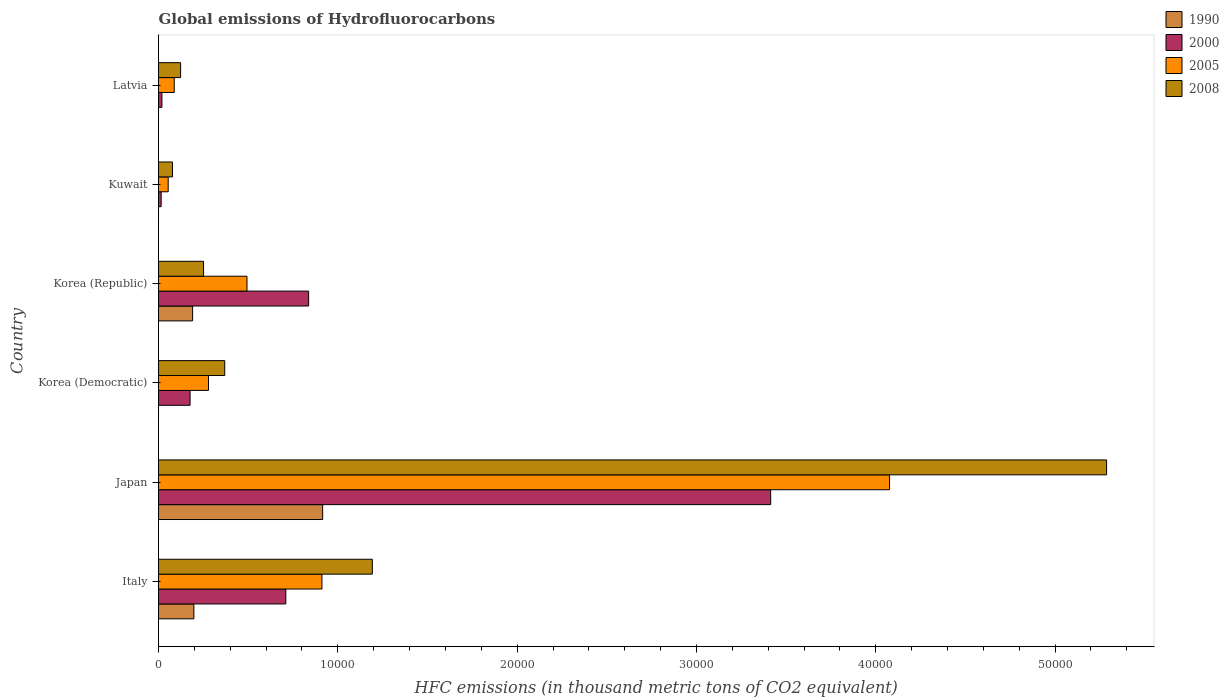How many groups of bars are there?
Make the answer very short. 6. Are the number of bars per tick equal to the number of legend labels?
Offer a very short reply. Yes. How many bars are there on the 6th tick from the bottom?
Keep it short and to the point. 4. What is the global emissions of Hydrofluorocarbons in 2005 in Korea (Republic)?
Keep it short and to the point. 4933.9. Across all countries, what is the maximum global emissions of Hydrofluorocarbons in 2005?
Provide a short and direct response. 4.08e+04. Across all countries, what is the minimum global emissions of Hydrofluorocarbons in 2008?
Ensure brevity in your answer.  779. In which country was the global emissions of Hydrofluorocarbons in 2005 minimum?
Provide a short and direct response. Kuwait. What is the total global emissions of Hydrofluorocarbons in 2000 in the graph?
Offer a very short reply. 5.17e+04. What is the difference between the global emissions of Hydrofluorocarbons in 2005 in Korea (Republic) and that in Latvia?
Give a very brief answer. 4057.3. What is the difference between the global emissions of Hydrofluorocarbons in 1990 in Japan and the global emissions of Hydrofluorocarbons in 2008 in Italy?
Offer a very short reply. -2770.2. What is the average global emissions of Hydrofluorocarbons in 1990 per country?
Your answer should be compact. 2171.43. What is the difference between the global emissions of Hydrofluorocarbons in 1990 and global emissions of Hydrofluorocarbons in 2000 in Kuwait?
Ensure brevity in your answer.  -147.2. What is the ratio of the global emissions of Hydrofluorocarbons in 2000 in Japan to that in Latvia?
Make the answer very short. 179.68. Is the global emissions of Hydrofluorocarbons in 2005 in Italy less than that in Japan?
Your answer should be compact. Yes. Is the difference between the global emissions of Hydrofluorocarbons in 1990 in Korea (Democratic) and Kuwait greater than the difference between the global emissions of Hydrofluorocarbons in 2000 in Korea (Democratic) and Kuwait?
Provide a succinct answer. No. What is the difference between the highest and the second highest global emissions of Hydrofluorocarbons in 1990?
Make the answer very short. 7182.1. What is the difference between the highest and the lowest global emissions of Hydrofluorocarbons in 2008?
Keep it short and to the point. 5.21e+04. In how many countries, is the global emissions of Hydrofluorocarbons in 2005 greater than the average global emissions of Hydrofluorocarbons in 2005 taken over all countries?
Offer a very short reply. 1. Is the sum of the global emissions of Hydrofluorocarbons in 2005 in Italy and Korea (Democratic) greater than the maximum global emissions of Hydrofluorocarbons in 2008 across all countries?
Your answer should be very brief. No. Is it the case that in every country, the sum of the global emissions of Hydrofluorocarbons in 2008 and global emissions of Hydrofluorocarbons in 2005 is greater than the global emissions of Hydrofluorocarbons in 1990?
Offer a very short reply. Yes. How many bars are there?
Your answer should be very brief. 24. What is the difference between two consecutive major ticks on the X-axis?
Provide a succinct answer. 10000. What is the title of the graph?
Your response must be concise. Global emissions of Hydrofluorocarbons. What is the label or title of the X-axis?
Your answer should be very brief. HFC emissions (in thousand metric tons of CO2 equivalent). What is the label or title of the Y-axis?
Your answer should be very brief. Country. What is the HFC emissions (in thousand metric tons of CO2 equivalent) of 1990 in Italy?
Ensure brevity in your answer.  1972.2. What is the HFC emissions (in thousand metric tons of CO2 equivalent) in 2000 in Italy?
Provide a succinct answer. 7099.5. What is the HFC emissions (in thousand metric tons of CO2 equivalent) of 2005 in Italy?
Give a very brief answer. 9114.5. What is the HFC emissions (in thousand metric tons of CO2 equivalent) in 2008 in Italy?
Make the answer very short. 1.19e+04. What is the HFC emissions (in thousand metric tons of CO2 equivalent) in 1990 in Japan?
Give a very brief answer. 9154.3. What is the HFC emissions (in thousand metric tons of CO2 equivalent) in 2000 in Japan?
Offer a very short reply. 3.41e+04. What is the HFC emissions (in thousand metric tons of CO2 equivalent) of 2005 in Japan?
Offer a very short reply. 4.08e+04. What is the HFC emissions (in thousand metric tons of CO2 equivalent) of 2008 in Japan?
Your answer should be compact. 5.29e+04. What is the HFC emissions (in thousand metric tons of CO2 equivalent) of 1990 in Korea (Democratic)?
Your answer should be very brief. 0.2. What is the HFC emissions (in thousand metric tons of CO2 equivalent) in 2000 in Korea (Democratic)?
Ensure brevity in your answer.  1760.1. What is the HFC emissions (in thousand metric tons of CO2 equivalent) in 2005 in Korea (Democratic)?
Make the answer very short. 2787.1. What is the HFC emissions (in thousand metric tons of CO2 equivalent) of 2008 in Korea (Democratic)?
Provide a short and direct response. 3693.8. What is the HFC emissions (in thousand metric tons of CO2 equivalent) of 1990 in Korea (Republic)?
Offer a terse response. 1901.7. What is the HFC emissions (in thousand metric tons of CO2 equivalent) of 2000 in Korea (Republic)?
Ensure brevity in your answer.  8371.9. What is the HFC emissions (in thousand metric tons of CO2 equivalent) of 2005 in Korea (Republic)?
Offer a very short reply. 4933.9. What is the HFC emissions (in thousand metric tons of CO2 equivalent) of 2008 in Korea (Republic)?
Provide a succinct answer. 2511.2. What is the HFC emissions (in thousand metric tons of CO2 equivalent) of 1990 in Kuwait?
Provide a short and direct response. 0.1. What is the HFC emissions (in thousand metric tons of CO2 equivalent) in 2000 in Kuwait?
Your response must be concise. 147.3. What is the HFC emissions (in thousand metric tons of CO2 equivalent) in 2005 in Kuwait?
Keep it short and to the point. 539.6. What is the HFC emissions (in thousand metric tons of CO2 equivalent) of 2008 in Kuwait?
Offer a very short reply. 779. What is the HFC emissions (in thousand metric tons of CO2 equivalent) in 2000 in Latvia?
Offer a terse response. 190. What is the HFC emissions (in thousand metric tons of CO2 equivalent) of 2005 in Latvia?
Make the answer very short. 876.6. What is the HFC emissions (in thousand metric tons of CO2 equivalent) of 2008 in Latvia?
Provide a succinct answer. 1233.1. Across all countries, what is the maximum HFC emissions (in thousand metric tons of CO2 equivalent) of 1990?
Provide a short and direct response. 9154.3. Across all countries, what is the maximum HFC emissions (in thousand metric tons of CO2 equivalent) of 2000?
Provide a succinct answer. 3.41e+04. Across all countries, what is the maximum HFC emissions (in thousand metric tons of CO2 equivalent) in 2005?
Provide a short and direct response. 4.08e+04. Across all countries, what is the maximum HFC emissions (in thousand metric tons of CO2 equivalent) in 2008?
Keep it short and to the point. 5.29e+04. Across all countries, what is the minimum HFC emissions (in thousand metric tons of CO2 equivalent) of 2000?
Your answer should be compact. 147.3. Across all countries, what is the minimum HFC emissions (in thousand metric tons of CO2 equivalent) in 2005?
Your response must be concise. 539.6. Across all countries, what is the minimum HFC emissions (in thousand metric tons of CO2 equivalent) of 2008?
Give a very brief answer. 779. What is the total HFC emissions (in thousand metric tons of CO2 equivalent) of 1990 in the graph?
Give a very brief answer. 1.30e+04. What is the total HFC emissions (in thousand metric tons of CO2 equivalent) of 2000 in the graph?
Keep it short and to the point. 5.17e+04. What is the total HFC emissions (in thousand metric tons of CO2 equivalent) in 2005 in the graph?
Your answer should be compact. 5.90e+04. What is the total HFC emissions (in thousand metric tons of CO2 equivalent) in 2008 in the graph?
Your answer should be very brief. 7.30e+04. What is the difference between the HFC emissions (in thousand metric tons of CO2 equivalent) in 1990 in Italy and that in Japan?
Provide a short and direct response. -7182.1. What is the difference between the HFC emissions (in thousand metric tons of CO2 equivalent) of 2000 in Italy and that in Japan?
Give a very brief answer. -2.70e+04. What is the difference between the HFC emissions (in thousand metric tons of CO2 equivalent) of 2005 in Italy and that in Japan?
Give a very brief answer. -3.17e+04. What is the difference between the HFC emissions (in thousand metric tons of CO2 equivalent) of 2008 in Italy and that in Japan?
Your response must be concise. -4.09e+04. What is the difference between the HFC emissions (in thousand metric tons of CO2 equivalent) in 1990 in Italy and that in Korea (Democratic)?
Provide a short and direct response. 1972. What is the difference between the HFC emissions (in thousand metric tons of CO2 equivalent) of 2000 in Italy and that in Korea (Democratic)?
Your answer should be compact. 5339.4. What is the difference between the HFC emissions (in thousand metric tons of CO2 equivalent) in 2005 in Italy and that in Korea (Democratic)?
Make the answer very short. 6327.4. What is the difference between the HFC emissions (in thousand metric tons of CO2 equivalent) of 2008 in Italy and that in Korea (Democratic)?
Provide a succinct answer. 8230.7. What is the difference between the HFC emissions (in thousand metric tons of CO2 equivalent) in 1990 in Italy and that in Korea (Republic)?
Offer a terse response. 70.5. What is the difference between the HFC emissions (in thousand metric tons of CO2 equivalent) in 2000 in Italy and that in Korea (Republic)?
Your answer should be compact. -1272.4. What is the difference between the HFC emissions (in thousand metric tons of CO2 equivalent) of 2005 in Italy and that in Korea (Republic)?
Your answer should be compact. 4180.6. What is the difference between the HFC emissions (in thousand metric tons of CO2 equivalent) of 2008 in Italy and that in Korea (Republic)?
Offer a terse response. 9413.3. What is the difference between the HFC emissions (in thousand metric tons of CO2 equivalent) of 1990 in Italy and that in Kuwait?
Your answer should be compact. 1972.1. What is the difference between the HFC emissions (in thousand metric tons of CO2 equivalent) in 2000 in Italy and that in Kuwait?
Your answer should be compact. 6952.2. What is the difference between the HFC emissions (in thousand metric tons of CO2 equivalent) of 2005 in Italy and that in Kuwait?
Provide a short and direct response. 8574.9. What is the difference between the HFC emissions (in thousand metric tons of CO2 equivalent) of 2008 in Italy and that in Kuwait?
Provide a short and direct response. 1.11e+04. What is the difference between the HFC emissions (in thousand metric tons of CO2 equivalent) in 1990 in Italy and that in Latvia?
Provide a short and direct response. 1972.1. What is the difference between the HFC emissions (in thousand metric tons of CO2 equivalent) of 2000 in Italy and that in Latvia?
Give a very brief answer. 6909.5. What is the difference between the HFC emissions (in thousand metric tons of CO2 equivalent) in 2005 in Italy and that in Latvia?
Give a very brief answer. 8237.9. What is the difference between the HFC emissions (in thousand metric tons of CO2 equivalent) in 2008 in Italy and that in Latvia?
Your response must be concise. 1.07e+04. What is the difference between the HFC emissions (in thousand metric tons of CO2 equivalent) in 1990 in Japan and that in Korea (Democratic)?
Make the answer very short. 9154.1. What is the difference between the HFC emissions (in thousand metric tons of CO2 equivalent) of 2000 in Japan and that in Korea (Democratic)?
Provide a short and direct response. 3.24e+04. What is the difference between the HFC emissions (in thousand metric tons of CO2 equivalent) of 2005 in Japan and that in Korea (Democratic)?
Your answer should be compact. 3.80e+04. What is the difference between the HFC emissions (in thousand metric tons of CO2 equivalent) of 2008 in Japan and that in Korea (Democratic)?
Keep it short and to the point. 4.92e+04. What is the difference between the HFC emissions (in thousand metric tons of CO2 equivalent) in 1990 in Japan and that in Korea (Republic)?
Your answer should be very brief. 7252.6. What is the difference between the HFC emissions (in thousand metric tons of CO2 equivalent) of 2000 in Japan and that in Korea (Republic)?
Offer a very short reply. 2.58e+04. What is the difference between the HFC emissions (in thousand metric tons of CO2 equivalent) in 2005 in Japan and that in Korea (Republic)?
Your answer should be compact. 3.58e+04. What is the difference between the HFC emissions (in thousand metric tons of CO2 equivalent) of 2008 in Japan and that in Korea (Republic)?
Provide a succinct answer. 5.04e+04. What is the difference between the HFC emissions (in thousand metric tons of CO2 equivalent) of 1990 in Japan and that in Kuwait?
Your answer should be compact. 9154.2. What is the difference between the HFC emissions (in thousand metric tons of CO2 equivalent) of 2000 in Japan and that in Kuwait?
Provide a succinct answer. 3.40e+04. What is the difference between the HFC emissions (in thousand metric tons of CO2 equivalent) in 2005 in Japan and that in Kuwait?
Offer a terse response. 4.02e+04. What is the difference between the HFC emissions (in thousand metric tons of CO2 equivalent) of 2008 in Japan and that in Kuwait?
Give a very brief answer. 5.21e+04. What is the difference between the HFC emissions (in thousand metric tons of CO2 equivalent) in 1990 in Japan and that in Latvia?
Your answer should be very brief. 9154.2. What is the difference between the HFC emissions (in thousand metric tons of CO2 equivalent) of 2000 in Japan and that in Latvia?
Keep it short and to the point. 3.39e+04. What is the difference between the HFC emissions (in thousand metric tons of CO2 equivalent) of 2005 in Japan and that in Latvia?
Offer a terse response. 3.99e+04. What is the difference between the HFC emissions (in thousand metric tons of CO2 equivalent) of 2008 in Japan and that in Latvia?
Your answer should be compact. 5.16e+04. What is the difference between the HFC emissions (in thousand metric tons of CO2 equivalent) in 1990 in Korea (Democratic) and that in Korea (Republic)?
Make the answer very short. -1901.5. What is the difference between the HFC emissions (in thousand metric tons of CO2 equivalent) of 2000 in Korea (Democratic) and that in Korea (Republic)?
Your answer should be compact. -6611.8. What is the difference between the HFC emissions (in thousand metric tons of CO2 equivalent) of 2005 in Korea (Democratic) and that in Korea (Republic)?
Provide a short and direct response. -2146.8. What is the difference between the HFC emissions (in thousand metric tons of CO2 equivalent) of 2008 in Korea (Democratic) and that in Korea (Republic)?
Ensure brevity in your answer.  1182.6. What is the difference between the HFC emissions (in thousand metric tons of CO2 equivalent) of 2000 in Korea (Democratic) and that in Kuwait?
Offer a very short reply. 1612.8. What is the difference between the HFC emissions (in thousand metric tons of CO2 equivalent) in 2005 in Korea (Democratic) and that in Kuwait?
Offer a terse response. 2247.5. What is the difference between the HFC emissions (in thousand metric tons of CO2 equivalent) in 2008 in Korea (Democratic) and that in Kuwait?
Make the answer very short. 2914.8. What is the difference between the HFC emissions (in thousand metric tons of CO2 equivalent) in 1990 in Korea (Democratic) and that in Latvia?
Your answer should be very brief. 0.1. What is the difference between the HFC emissions (in thousand metric tons of CO2 equivalent) in 2000 in Korea (Democratic) and that in Latvia?
Your response must be concise. 1570.1. What is the difference between the HFC emissions (in thousand metric tons of CO2 equivalent) of 2005 in Korea (Democratic) and that in Latvia?
Offer a very short reply. 1910.5. What is the difference between the HFC emissions (in thousand metric tons of CO2 equivalent) of 2008 in Korea (Democratic) and that in Latvia?
Provide a succinct answer. 2460.7. What is the difference between the HFC emissions (in thousand metric tons of CO2 equivalent) in 1990 in Korea (Republic) and that in Kuwait?
Ensure brevity in your answer.  1901.6. What is the difference between the HFC emissions (in thousand metric tons of CO2 equivalent) in 2000 in Korea (Republic) and that in Kuwait?
Provide a succinct answer. 8224.6. What is the difference between the HFC emissions (in thousand metric tons of CO2 equivalent) in 2005 in Korea (Republic) and that in Kuwait?
Your answer should be compact. 4394.3. What is the difference between the HFC emissions (in thousand metric tons of CO2 equivalent) in 2008 in Korea (Republic) and that in Kuwait?
Your response must be concise. 1732.2. What is the difference between the HFC emissions (in thousand metric tons of CO2 equivalent) in 1990 in Korea (Republic) and that in Latvia?
Offer a terse response. 1901.6. What is the difference between the HFC emissions (in thousand metric tons of CO2 equivalent) in 2000 in Korea (Republic) and that in Latvia?
Provide a short and direct response. 8181.9. What is the difference between the HFC emissions (in thousand metric tons of CO2 equivalent) of 2005 in Korea (Republic) and that in Latvia?
Make the answer very short. 4057.3. What is the difference between the HFC emissions (in thousand metric tons of CO2 equivalent) of 2008 in Korea (Republic) and that in Latvia?
Your answer should be very brief. 1278.1. What is the difference between the HFC emissions (in thousand metric tons of CO2 equivalent) of 1990 in Kuwait and that in Latvia?
Your answer should be compact. 0. What is the difference between the HFC emissions (in thousand metric tons of CO2 equivalent) in 2000 in Kuwait and that in Latvia?
Offer a terse response. -42.7. What is the difference between the HFC emissions (in thousand metric tons of CO2 equivalent) of 2005 in Kuwait and that in Latvia?
Ensure brevity in your answer.  -337. What is the difference between the HFC emissions (in thousand metric tons of CO2 equivalent) in 2008 in Kuwait and that in Latvia?
Keep it short and to the point. -454.1. What is the difference between the HFC emissions (in thousand metric tons of CO2 equivalent) of 1990 in Italy and the HFC emissions (in thousand metric tons of CO2 equivalent) of 2000 in Japan?
Keep it short and to the point. -3.22e+04. What is the difference between the HFC emissions (in thousand metric tons of CO2 equivalent) in 1990 in Italy and the HFC emissions (in thousand metric tons of CO2 equivalent) in 2005 in Japan?
Ensure brevity in your answer.  -3.88e+04. What is the difference between the HFC emissions (in thousand metric tons of CO2 equivalent) of 1990 in Italy and the HFC emissions (in thousand metric tons of CO2 equivalent) of 2008 in Japan?
Give a very brief answer. -5.09e+04. What is the difference between the HFC emissions (in thousand metric tons of CO2 equivalent) of 2000 in Italy and the HFC emissions (in thousand metric tons of CO2 equivalent) of 2005 in Japan?
Offer a terse response. -3.37e+04. What is the difference between the HFC emissions (in thousand metric tons of CO2 equivalent) in 2000 in Italy and the HFC emissions (in thousand metric tons of CO2 equivalent) in 2008 in Japan?
Your answer should be compact. -4.58e+04. What is the difference between the HFC emissions (in thousand metric tons of CO2 equivalent) in 2005 in Italy and the HFC emissions (in thousand metric tons of CO2 equivalent) in 2008 in Japan?
Provide a succinct answer. -4.38e+04. What is the difference between the HFC emissions (in thousand metric tons of CO2 equivalent) of 1990 in Italy and the HFC emissions (in thousand metric tons of CO2 equivalent) of 2000 in Korea (Democratic)?
Your answer should be compact. 212.1. What is the difference between the HFC emissions (in thousand metric tons of CO2 equivalent) in 1990 in Italy and the HFC emissions (in thousand metric tons of CO2 equivalent) in 2005 in Korea (Democratic)?
Offer a terse response. -814.9. What is the difference between the HFC emissions (in thousand metric tons of CO2 equivalent) of 1990 in Italy and the HFC emissions (in thousand metric tons of CO2 equivalent) of 2008 in Korea (Democratic)?
Your answer should be very brief. -1721.6. What is the difference between the HFC emissions (in thousand metric tons of CO2 equivalent) of 2000 in Italy and the HFC emissions (in thousand metric tons of CO2 equivalent) of 2005 in Korea (Democratic)?
Your answer should be very brief. 4312.4. What is the difference between the HFC emissions (in thousand metric tons of CO2 equivalent) in 2000 in Italy and the HFC emissions (in thousand metric tons of CO2 equivalent) in 2008 in Korea (Democratic)?
Your response must be concise. 3405.7. What is the difference between the HFC emissions (in thousand metric tons of CO2 equivalent) of 2005 in Italy and the HFC emissions (in thousand metric tons of CO2 equivalent) of 2008 in Korea (Democratic)?
Provide a succinct answer. 5420.7. What is the difference between the HFC emissions (in thousand metric tons of CO2 equivalent) in 1990 in Italy and the HFC emissions (in thousand metric tons of CO2 equivalent) in 2000 in Korea (Republic)?
Keep it short and to the point. -6399.7. What is the difference between the HFC emissions (in thousand metric tons of CO2 equivalent) in 1990 in Italy and the HFC emissions (in thousand metric tons of CO2 equivalent) in 2005 in Korea (Republic)?
Give a very brief answer. -2961.7. What is the difference between the HFC emissions (in thousand metric tons of CO2 equivalent) in 1990 in Italy and the HFC emissions (in thousand metric tons of CO2 equivalent) in 2008 in Korea (Republic)?
Offer a very short reply. -539. What is the difference between the HFC emissions (in thousand metric tons of CO2 equivalent) of 2000 in Italy and the HFC emissions (in thousand metric tons of CO2 equivalent) of 2005 in Korea (Republic)?
Your answer should be compact. 2165.6. What is the difference between the HFC emissions (in thousand metric tons of CO2 equivalent) in 2000 in Italy and the HFC emissions (in thousand metric tons of CO2 equivalent) in 2008 in Korea (Republic)?
Make the answer very short. 4588.3. What is the difference between the HFC emissions (in thousand metric tons of CO2 equivalent) of 2005 in Italy and the HFC emissions (in thousand metric tons of CO2 equivalent) of 2008 in Korea (Republic)?
Make the answer very short. 6603.3. What is the difference between the HFC emissions (in thousand metric tons of CO2 equivalent) of 1990 in Italy and the HFC emissions (in thousand metric tons of CO2 equivalent) of 2000 in Kuwait?
Provide a succinct answer. 1824.9. What is the difference between the HFC emissions (in thousand metric tons of CO2 equivalent) of 1990 in Italy and the HFC emissions (in thousand metric tons of CO2 equivalent) of 2005 in Kuwait?
Make the answer very short. 1432.6. What is the difference between the HFC emissions (in thousand metric tons of CO2 equivalent) of 1990 in Italy and the HFC emissions (in thousand metric tons of CO2 equivalent) of 2008 in Kuwait?
Provide a succinct answer. 1193.2. What is the difference between the HFC emissions (in thousand metric tons of CO2 equivalent) in 2000 in Italy and the HFC emissions (in thousand metric tons of CO2 equivalent) in 2005 in Kuwait?
Provide a short and direct response. 6559.9. What is the difference between the HFC emissions (in thousand metric tons of CO2 equivalent) of 2000 in Italy and the HFC emissions (in thousand metric tons of CO2 equivalent) of 2008 in Kuwait?
Your answer should be compact. 6320.5. What is the difference between the HFC emissions (in thousand metric tons of CO2 equivalent) in 2005 in Italy and the HFC emissions (in thousand metric tons of CO2 equivalent) in 2008 in Kuwait?
Your answer should be compact. 8335.5. What is the difference between the HFC emissions (in thousand metric tons of CO2 equivalent) of 1990 in Italy and the HFC emissions (in thousand metric tons of CO2 equivalent) of 2000 in Latvia?
Make the answer very short. 1782.2. What is the difference between the HFC emissions (in thousand metric tons of CO2 equivalent) in 1990 in Italy and the HFC emissions (in thousand metric tons of CO2 equivalent) in 2005 in Latvia?
Keep it short and to the point. 1095.6. What is the difference between the HFC emissions (in thousand metric tons of CO2 equivalent) in 1990 in Italy and the HFC emissions (in thousand metric tons of CO2 equivalent) in 2008 in Latvia?
Ensure brevity in your answer.  739.1. What is the difference between the HFC emissions (in thousand metric tons of CO2 equivalent) of 2000 in Italy and the HFC emissions (in thousand metric tons of CO2 equivalent) of 2005 in Latvia?
Offer a very short reply. 6222.9. What is the difference between the HFC emissions (in thousand metric tons of CO2 equivalent) in 2000 in Italy and the HFC emissions (in thousand metric tons of CO2 equivalent) in 2008 in Latvia?
Your answer should be compact. 5866.4. What is the difference between the HFC emissions (in thousand metric tons of CO2 equivalent) of 2005 in Italy and the HFC emissions (in thousand metric tons of CO2 equivalent) of 2008 in Latvia?
Your answer should be very brief. 7881.4. What is the difference between the HFC emissions (in thousand metric tons of CO2 equivalent) of 1990 in Japan and the HFC emissions (in thousand metric tons of CO2 equivalent) of 2000 in Korea (Democratic)?
Ensure brevity in your answer.  7394.2. What is the difference between the HFC emissions (in thousand metric tons of CO2 equivalent) in 1990 in Japan and the HFC emissions (in thousand metric tons of CO2 equivalent) in 2005 in Korea (Democratic)?
Ensure brevity in your answer.  6367.2. What is the difference between the HFC emissions (in thousand metric tons of CO2 equivalent) of 1990 in Japan and the HFC emissions (in thousand metric tons of CO2 equivalent) of 2008 in Korea (Democratic)?
Give a very brief answer. 5460.5. What is the difference between the HFC emissions (in thousand metric tons of CO2 equivalent) in 2000 in Japan and the HFC emissions (in thousand metric tons of CO2 equivalent) in 2005 in Korea (Democratic)?
Your answer should be very brief. 3.14e+04. What is the difference between the HFC emissions (in thousand metric tons of CO2 equivalent) in 2000 in Japan and the HFC emissions (in thousand metric tons of CO2 equivalent) in 2008 in Korea (Democratic)?
Keep it short and to the point. 3.04e+04. What is the difference between the HFC emissions (in thousand metric tons of CO2 equivalent) in 2005 in Japan and the HFC emissions (in thousand metric tons of CO2 equivalent) in 2008 in Korea (Democratic)?
Offer a terse response. 3.71e+04. What is the difference between the HFC emissions (in thousand metric tons of CO2 equivalent) in 1990 in Japan and the HFC emissions (in thousand metric tons of CO2 equivalent) in 2000 in Korea (Republic)?
Offer a very short reply. 782.4. What is the difference between the HFC emissions (in thousand metric tons of CO2 equivalent) of 1990 in Japan and the HFC emissions (in thousand metric tons of CO2 equivalent) of 2005 in Korea (Republic)?
Offer a terse response. 4220.4. What is the difference between the HFC emissions (in thousand metric tons of CO2 equivalent) of 1990 in Japan and the HFC emissions (in thousand metric tons of CO2 equivalent) of 2008 in Korea (Republic)?
Keep it short and to the point. 6643.1. What is the difference between the HFC emissions (in thousand metric tons of CO2 equivalent) of 2000 in Japan and the HFC emissions (in thousand metric tons of CO2 equivalent) of 2005 in Korea (Republic)?
Your answer should be very brief. 2.92e+04. What is the difference between the HFC emissions (in thousand metric tons of CO2 equivalent) of 2000 in Japan and the HFC emissions (in thousand metric tons of CO2 equivalent) of 2008 in Korea (Republic)?
Offer a terse response. 3.16e+04. What is the difference between the HFC emissions (in thousand metric tons of CO2 equivalent) of 2005 in Japan and the HFC emissions (in thousand metric tons of CO2 equivalent) of 2008 in Korea (Republic)?
Ensure brevity in your answer.  3.83e+04. What is the difference between the HFC emissions (in thousand metric tons of CO2 equivalent) in 1990 in Japan and the HFC emissions (in thousand metric tons of CO2 equivalent) in 2000 in Kuwait?
Ensure brevity in your answer.  9007. What is the difference between the HFC emissions (in thousand metric tons of CO2 equivalent) in 1990 in Japan and the HFC emissions (in thousand metric tons of CO2 equivalent) in 2005 in Kuwait?
Make the answer very short. 8614.7. What is the difference between the HFC emissions (in thousand metric tons of CO2 equivalent) of 1990 in Japan and the HFC emissions (in thousand metric tons of CO2 equivalent) of 2008 in Kuwait?
Your answer should be compact. 8375.3. What is the difference between the HFC emissions (in thousand metric tons of CO2 equivalent) of 2000 in Japan and the HFC emissions (in thousand metric tons of CO2 equivalent) of 2005 in Kuwait?
Your answer should be very brief. 3.36e+04. What is the difference between the HFC emissions (in thousand metric tons of CO2 equivalent) of 2000 in Japan and the HFC emissions (in thousand metric tons of CO2 equivalent) of 2008 in Kuwait?
Your response must be concise. 3.34e+04. What is the difference between the HFC emissions (in thousand metric tons of CO2 equivalent) of 2005 in Japan and the HFC emissions (in thousand metric tons of CO2 equivalent) of 2008 in Kuwait?
Your answer should be very brief. 4.00e+04. What is the difference between the HFC emissions (in thousand metric tons of CO2 equivalent) in 1990 in Japan and the HFC emissions (in thousand metric tons of CO2 equivalent) in 2000 in Latvia?
Provide a short and direct response. 8964.3. What is the difference between the HFC emissions (in thousand metric tons of CO2 equivalent) of 1990 in Japan and the HFC emissions (in thousand metric tons of CO2 equivalent) of 2005 in Latvia?
Offer a very short reply. 8277.7. What is the difference between the HFC emissions (in thousand metric tons of CO2 equivalent) of 1990 in Japan and the HFC emissions (in thousand metric tons of CO2 equivalent) of 2008 in Latvia?
Your answer should be very brief. 7921.2. What is the difference between the HFC emissions (in thousand metric tons of CO2 equivalent) of 2000 in Japan and the HFC emissions (in thousand metric tons of CO2 equivalent) of 2005 in Latvia?
Provide a succinct answer. 3.33e+04. What is the difference between the HFC emissions (in thousand metric tons of CO2 equivalent) in 2000 in Japan and the HFC emissions (in thousand metric tons of CO2 equivalent) in 2008 in Latvia?
Your answer should be very brief. 3.29e+04. What is the difference between the HFC emissions (in thousand metric tons of CO2 equivalent) of 2005 in Japan and the HFC emissions (in thousand metric tons of CO2 equivalent) of 2008 in Latvia?
Your answer should be very brief. 3.95e+04. What is the difference between the HFC emissions (in thousand metric tons of CO2 equivalent) of 1990 in Korea (Democratic) and the HFC emissions (in thousand metric tons of CO2 equivalent) of 2000 in Korea (Republic)?
Provide a succinct answer. -8371.7. What is the difference between the HFC emissions (in thousand metric tons of CO2 equivalent) in 1990 in Korea (Democratic) and the HFC emissions (in thousand metric tons of CO2 equivalent) in 2005 in Korea (Republic)?
Provide a succinct answer. -4933.7. What is the difference between the HFC emissions (in thousand metric tons of CO2 equivalent) in 1990 in Korea (Democratic) and the HFC emissions (in thousand metric tons of CO2 equivalent) in 2008 in Korea (Republic)?
Your response must be concise. -2511. What is the difference between the HFC emissions (in thousand metric tons of CO2 equivalent) of 2000 in Korea (Democratic) and the HFC emissions (in thousand metric tons of CO2 equivalent) of 2005 in Korea (Republic)?
Provide a succinct answer. -3173.8. What is the difference between the HFC emissions (in thousand metric tons of CO2 equivalent) of 2000 in Korea (Democratic) and the HFC emissions (in thousand metric tons of CO2 equivalent) of 2008 in Korea (Republic)?
Provide a short and direct response. -751.1. What is the difference between the HFC emissions (in thousand metric tons of CO2 equivalent) in 2005 in Korea (Democratic) and the HFC emissions (in thousand metric tons of CO2 equivalent) in 2008 in Korea (Republic)?
Your answer should be compact. 275.9. What is the difference between the HFC emissions (in thousand metric tons of CO2 equivalent) in 1990 in Korea (Democratic) and the HFC emissions (in thousand metric tons of CO2 equivalent) in 2000 in Kuwait?
Keep it short and to the point. -147.1. What is the difference between the HFC emissions (in thousand metric tons of CO2 equivalent) in 1990 in Korea (Democratic) and the HFC emissions (in thousand metric tons of CO2 equivalent) in 2005 in Kuwait?
Provide a succinct answer. -539.4. What is the difference between the HFC emissions (in thousand metric tons of CO2 equivalent) of 1990 in Korea (Democratic) and the HFC emissions (in thousand metric tons of CO2 equivalent) of 2008 in Kuwait?
Your answer should be very brief. -778.8. What is the difference between the HFC emissions (in thousand metric tons of CO2 equivalent) of 2000 in Korea (Democratic) and the HFC emissions (in thousand metric tons of CO2 equivalent) of 2005 in Kuwait?
Make the answer very short. 1220.5. What is the difference between the HFC emissions (in thousand metric tons of CO2 equivalent) in 2000 in Korea (Democratic) and the HFC emissions (in thousand metric tons of CO2 equivalent) in 2008 in Kuwait?
Ensure brevity in your answer.  981.1. What is the difference between the HFC emissions (in thousand metric tons of CO2 equivalent) of 2005 in Korea (Democratic) and the HFC emissions (in thousand metric tons of CO2 equivalent) of 2008 in Kuwait?
Your answer should be compact. 2008.1. What is the difference between the HFC emissions (in thousand metric tons of CO2 equivalent) of 1990 in Korea (Democratic) and the HFC emissions (in thousand metric tons of CO2 equivalent) of 2000 in Latvia?
Provide a succinct answer. -189.8. What is the difference between the HFC emissions (in thousand metric tons of CO2 equivalent) in 1990 in Korea (Democratic) and the HFC emissions (in thousand metric tons of CO2 equivalent) in 2005 in Latvia?
Ensure brevity in your answer.  -876.4. What is the difference between the HFC emissions (in thousand metric tons of CO2 equivalent) in 1990 in Korea (Democratic) and the HFC emissions (in thousand metric tons of CO2 equivalent) in 2008 in Latvia?
Offer a very short reply. -1232.9. What is the difference between the HFC emissions (in thousand metric tons of CO2 equivalent) in 2000 in Korea (Democratic) and the HFC emissions (in thousand metric tons of CO2 equivalent) in 2005 in Latvia?
Your response must be concise. 883.5. What is the difference between the HFC emissions (in thousand metric tons of CO2 equivalent) of 2000 in Korea (Democratic) and the HFC emissions (in thousand metric tons of CO2 equivalent) of 2008 in Latvia?
Your response must be concise. 527. What is the difference between the HFC emissions (in thousand metric tons of CO2 equivalent) of 2005 in Korea (Democratic) and the HFC emissions (in thousand metric tons of CO2 equivalent) of 2008 in Latvia?
Provide a succinct answer. 1554. What is the difference between the HFC emissions (in thousand metric tons of CO2 equivalent) in 1990 in Korea (Republic) and the HFC emissions (in thousand metric tons of CO2 equivalent) in 2000 in Kuwait?
Ensure brevity in your answer.  1754.4. What is the difference between the HFC emissions (in thousand metric tons of CO2 equivalent) in 1990 in Korea (Republic) and the HFC emissions (in thousand metric tons of CO2 equivalent) in 2005 in Kuwait?
Provide a succinct answer. 1362.1. What is the difference between the HFC emissions (in thousand metric tons of CO2 equivalent) in 1990 in Korea (Republic) and the HFC emissions (in thousand metric tons of CO2 equivalent) in 2008 in Kuwait?
Your response must be concise. 1122.7. What is the difference between the HFC emissions (in thousand metric tons of CO2 equivalent) of 2000 in Korea (Republic) and the HFC emissions (in thousand metric tons of CO2 equivalent) of 2005 in Kuwait?
Ensure brevity in your answer.  7832.3. What is the difference between the HFC emissions (in thousand metric tons of CO2 equivalent) in 2000 in Korea (Republic) and the HFC emissions (in thousand metric tons of CO2 equivalent) in 2008 in Kuwait?
Keep it short and to the point. 7592.9. What is the difference between the HFC emissions (in thousand metric tons of CO2 equivalent) of 2005 in Korea (Republic) and the HFC emissions (in thousand metric tons of CO2 equivalent) of 2008 in Kuwait?
Your answer should be very brief. 4154.9. What is the difference between the HFC emissions (in thousand metric tons of CO2 equivalent) of 1990 in Korea (Republic) and the HFC emissions (in thousand metric tons of CO2 equivalent) of 2000 in Latvia?
Make the answer very short. 1711.7. What is the difference between the HFC emissions (in thousand metric tons of CO2 equivalent) of 1990 in Korea (Republic) and the HFC emissions (in thousand metric tons of CO2 equivalent) of 2005 in Latvia?
Provide a short and direct response. 1025.1. What is the difference between the HFC emissions (in thousand metric tons of CO2 equivalent) in 1990 in Korea (Republic) and the HFC emissions (in thousand metric tons of CO2 equivalent) in 2008 in Latvia?
Provide a short and direct response. 668.6. What is the difference between the HFC emissions (in thousand metric tons of CO2 equivalent) in 2000 in Korea (Republic) and the HFC emissions (in thousand metric tons of CO2 equivalent) in 2005 in Latvia?
Your response must be concise. 7495.3. What is the difference between the HFC emissions (in thousand metric tons of CO2 equivalent) in 2000 in Korea (Republic) and the HFC emissions (in thousand metric tons of CO2 equivalent) in 2008 in Latvia?
Ensure brevity in your answer.  7138.8. What is the difference between the HFC emissions (in thousand metric tons of CO2 equivalent) in 2005 in Korea (Republic) and the HFC emissions (in thousand metric tons of CO2 equivalent) in 2008 in Latvia?
Ensure brevity in your answer.  3700.8. What is the difference between the HFC emissions (in thousand metric tons of CO2 equivalent) of 1990 in Kuwait and the HFC emissions (in thousand metric tons of CO2 equivalent) of 2000 in Latvia?
Offer a very short reply. -189.9. What is the difference between the HFC emissions (in thousand metric tons of CO2 equivalent) in 1990 in Kuwait and the HFC emissions (in thousand metric tons of CO2 equivalent) in 2005 in Latvia?
Your answer should be very brief. -876.5. What is the difference between the HFC emissions (in thousand metric tons of CO2 equivalent) in 1990 in Kuwait and the HFC emissions (in thousand metric tons of CO2 equivalent) in 2008 in Latvia?
Make the answer very short. -1233. What is the difference between the HFC emissions (in thousand metric tons of CO2 equivalent) of 2000 in Kuwait and the HFC emissions (in thousand metric tons of CO2 equivalent) of 2005 in Latvia?
Your answer should be very brief. -729.3. What is the difference between the HFC emissions (in thousand metric tons of CO2 equivalent) in 2000 in Kuwait and the HFC emissions (in thousand metric tons of CO2 equivalent) in 2008 in Latvia?
Provide a succinct answer. -1085.8. What is the difference between the HFC emissions (in thousand metric tons of CO2 equivalent) of 2005 in Kuwait and the HFC emissions (in thousand metric tons of CO2 equivalent) of 2008 in Latvia?
Your answer should be very brief. -693.5. What is the average HFC emissions (in thousand metric tons of CO2 equivalent) of 1990 per country?
Your answer should be compact. 2171.43. What is the average HFC emissions (in thousand metric tons of CO2 equivalent) in 2000 per country?
Your answer should be compact. 8618.1. What is the average HFC emissions (in thousand metric tons of CO2 equivalent) in 2005 per country?
Your response must be concise. 9836.7. What is the average HFC emissions (in thousand metric tons of CO2 equivalent) of 2008 per country?
Make the answer very short. 1.22e+04. What is the difference between the HFC emissions (in thousand metric tons of CO2 equivalent) of 1990 and HFC emissions (in thousand metric tons of CO2 equivalent) of 2000 in Italy?
Your answer should be very brief. -5127.3. What is the difference between the HFC emissions (in thousand metric tons of CO2 equivalent) in 1990 and HFC emissions (in thousand metric tons of CO2 equivalent) in 2005 in Italy?
Your answer should be very brief. -7142.3. What is the difference between the HFC emissions (in thousand metric tons of CO2 equivalent) of 1990 and HFC emissions (in thousand metric tons of CO2 equivalent) of 2008 in Italy?
Provide a short and direct response. -9952.3. What is the difference between the HFC emissions (in thousand metric tons of CO2 equivalent) in 2000 and HFC emissions (in thousand metric tons of CO2 equivalent) in 2005 in Italy?
Ensure brevity in your answer.  -2015. What is the difference between the HFC emissions (in thousand metric tons of CO2 equivalent) in 2000 and HFC emissions (in thousand metric tons of CO2 equivalent) in 2008 in Italy?
Give a very brief answer. -4825. What is the difference between the HFC emissions (in thousand metric tons of CO2 equivalent) of 2005 and HFC emissions (in thousand metric tons of CO2 equivalent) of 2008 in Italy?
Offer a very short reply. -2810. What is the difference between the HFC emissions (in thousand metric tons of CO2 equivalent) in 1990 and HFC emissions (in thousand metric tons of CO2 equivalent) in 2000 in Japan?
Keep it short and to the point. -2.50e+04. What is the difference between the HFC emissions (in thousand metric tons of CO2 equivalent) in 1990 and HFC emissions (in thousand metric tons of CO2 equivalent) in 2005 in Japan?
Your response must be concise. -3.16e+04. What is the difference between the HFC emissions (in thousand metric tons of CO2 equivalent) of 1990 and HFC emissions (in thousand metric tons of CO2 equivalent) of 2008 in Japan?
Provide a short and direct response. -4.37e+04. What is the difference between the HFC emissions (in thousand metric tons of CO2 equivalent) in 2000 and HFC emissions (in thousand metric tons of CO2 equivalent) in 2005 in Japan?
Ensure brevity in your answer.  -6628.7. What is the difference between the HFC emissions (in thousand metric tons of CO2 equivalent) in 2000 and HFC emissions (in thousand metric tons of CO2 equivalent) in 2008 in Japan?
Your answer should be compact. -1.87e+04. What is the difference between the HFC emissions (in thousand metric tons of CO2 equivalent) in 2005 and HFC emissions (in thousand metric tons of CO2 equivalent) in 2008 in Japan?
Provide a succinct answer. -1.21e+04. What is the difference between the HFC emissions (in thousand metric tons of CO2 equivalent) in 1990 and HFC emissions (in thousand metric tons of CO2 equivalent) in 2000 in Korea (Democratic)?
Offer a very short reply. -1759.9. What is the difference between the HFC emissions (in thousand metric tons of CO2 equivalent) of 1990 and HFC emissions (in thousand metric tons of CO2 equivalent) of 2005 in Korea (Democratic)?
Keep it short and to the point. -2786.9. What is the difference between the HFC emissions (in thousand metric tons of CO2 equivalent) in 1990 and HFC emissions (in thousand metric tons of CO2 equivalent) in 2008 in Korea (Democratic)?
Your response must be concise. -3693.6. What is the difference between the HFC emissions (in thousand metric tons of CO2 equivalent) of 2000 and HFC emissions (in thousand metric tons of CO2 equivalent) of 2005 in Korea (Democratic)?
Keep it short and to the point. -1027. What is the difference between the HFC emissions (in thousand metric tons of CO2 equivalent) in 2000 and HFC emissions (in thousand metric tons of CO2 equivalent) in 2008 in Korea (Democratic)?
Keep it short and to the point. -1933.7. What is the difference between the HFC emissions (in thousand metric tons of CO2 equivalent) of 2005 and HFC emissions (in thousand metric tons of CO2 equivalent) of 2008 in Korea (Democratic)?
Offer a terse response. -906.7. What is the difference between the HFC emissions (in thousand metric tons of CO2 equivalent) of 1990 and HFC emissions (in thousand metric tons of CO2 equivalent) of 2000 in Korea (Republic)?
Keep it short and to the point. -6470.2. What is the difference between the HFC emissions (in thousand metric tons of CO2 equivalent) in 1990 and HFC emissions (in thousand metric tons of CO2 equivalent) in 2005 in Korea (Republic)?
Your answer should be very brief. -3032.2. What is the difference between the HFC emissions (in thousand metric tons of CO2 equivalent) of 1990 and HFC emissions (in thousand metric tons of CO2 equivalent) of 2008 in Korea (Republic)?
Your answer should be very brief. -609.5. What is the difference between the HFC emissions (in thousand metric tons of CO2 equivalent) of 2000 and HFC emissions (in thousand metric tons of CO2 equivalent) of 2005 in Korea (Republic)?
Make the answer very short. 3438. What is the difference between the HFC emissions (in thousand metric tons of CO2 equivalent) of 2000 and HFC emissions (in thousand metric tons of CO2 equivalent) of 2008 in Korea (Republic)?
Give a very brief answer. 5860.7. What is the difference between the HFC emissions (in thousand metric tons of CO2 equivalent) of 2005 and HFC emissions (in thousand metric tons of CO2 equivalent) of 2008 in Korea (Republic)?
Provide a short and direct response. 2422.7. What is the difference between the HFC emissions (in thousand metric tons of CO2 equivalent) in 1990 and HFC emissions (in thousand metric tons of CO2 equivalent) in 2000 in Kuwait?
Make the answer very short. -147.2. What is the difference between the HFC emissions (in thousand metric tons of CO2 equivalent) of 1990 and HFC emissions (in thousand metric tons of CO2 equivalent) of 2005 in Kuwait?
Offer a very short reply. -539.5. What is the difference between the HFC emissions (in thousand metric tons of CO2 equivalent) in 1990 and HFC emissions (in thousand metric tons of CO2 equivalent) in 2008 in Kuwait?
Ensure brevity in your answer.  -778.9. What is the difference between the HFC emissions (in thousand metric tons of CO2 equivalent) in 2000 and HFC emissions (in thousand metric tons of CO2 equivalent) in 2005 in Kuwait?
Ensure brevity in your answer.  -392.3. What is the difference between the HFC emissions (in thousand metric tons of CO2 equivalent) of 2000 and HFC emissions (in thousand metric tons of CO2 equivalent) of 2008 in Kuwait?
Keep it short and to the point. -631.7. What is the difference between the HFC emissions (in thousand metric tons of CO2 equivalent) in 2005 and HFC emissions (in thousand metric tons of CO2 equivalent) in 2008 in Kuwait?
Offer a very short reply. -239.4. What is the difference between the HFC emissions (in thousand metric tons of CO2 equivalent) of 1990 and HFC emissions (in thousand metric tons of CO2 equivalent) of 2000 in Latvia?
Provide a succinct answer. -189.9. What is the difference between the HFC emissions (in thousand metric tons of CO2 equivalent) of 1990 and HFC emissions (in thousand metric tons of CO2 equivalent) of 2005 in Latvia?
Your answer should be very brief. -876.5. What is the difference between the HFC emissions (in thousand metric tons of CO2 equivalent) in 1990 and HFC emissions (in thousand metric tons of CO2 equivalent) in 2008 in Latvia?
Offer a very short reply. -1233. What is the difference between the HFC emissions (in thousand metric tons of CO2 equivalent) in 2000 and HFC emissions (in thousand metric tons of CO2 equivalent) in 2005 in Latvia?
Ensure brevity in your answer.  -686.6. What is the difference between the HFC emissions (in thousand metric tons of CO2 equivalent) of 2000 and HFC emissions (in thousand metric tons of CO2 equivalent) of 2008 in Latvia?
Your answer should be compact. -1043.1. What is the difference between the HFC emissions (in thousand metric tons of CO2 equivalent) in 2005 and HFC emissions (in thousand metric tons of CO2 equivalent) in 2008 in Latvia?
Keep it short and to the point. -356.5. What is the ratio of the HFC emissions (in thousand metric tons of CO2 equivalent) of 1990 in Italy to that in Japan?
Your response must be concise. 0.22. What is the ratio of the HFC emissions (in thousand metric tons of CO2 equivalent) of 2000 in Italy to that in Japan?
Provide a short and direct response. 0.21. What is the ratio of the HFC emissions (in thousand metric tons of CO2 equivalent) of 2005 in Italy to that in Japan?
Make the answer very short. 0.22. What is the ratio of the HFC emissions (in thousand metric tons of CO2 equivalent) of 2008 in Italy to that in Japan?
Your answer should be compact. 0.23. What is the ratio of the HFC emissions (in thousand metric tons of CO2 equivalent) in 1990 in Italy to that in Korea (Democratic)?
Your response must be concise. 9861. What is the ratio of the HFC emissions (in thousand metric tons of CO2 equivalent) of 2000 in Italy to that in Korea (Democratic)?
Offer a very short reply. 4.03. What is the ratio of the HFC emissions (in thousand metric tons of CO2 equivalent) of 2005 in Italy to that in Korea (Democratic)?
Your answer should be very brief. 3.27. What is the ratio of the HFC emissions (in thousand metric tons of CO2 equivalent) in 2008 in Italy to that in Korea (Democratic)?
Make the answer very short. 3.23. What is the ratio of the HFC emissions (in thousand metric tons of CO2 equivalent) of 1990 in Italy to that in Korea (Republic)?
Your answer should be compact. 1.04. What is the ratio of the HFC emissions (in thousand metric tons of CO2 equivalent) in 2000 in Italy to that in Korea (Republic)?
Provide a short and direct response. 0.85. What is the ratio of the HFC emissions (in thousand metric tons of CO2 equivalent) of 2005 in Italy to that in Korea (Republic)?
Make the answer very short. 1.85. What is the ratio of the HFC emissions (in thousand metric tons of CO2 equivalent) in 2008 in Italy to that in Korea (Republic)?
Keep it short and to the point. 4.75. What is the ratio of the HFC emissions (in thousand metric tons of CO2 equivalent) of 1990 in Italy to that in Kuwait?
Make the answer very short. 1.97e+04. What is the ratio of the HFC emissions (in thousand metric tons of CO2 equivalent) in 2000 in Italy to that in Kuwait?
Provide a succinct answer. 48.2. What is the ratio of the HFC emissions (in thousand metric tons of CO2 equivalent) of 2005 in Italy to that in Kuwait?
Offer a terse response. 16.89. What is the ratio of the HFC emissions (in thousand metric tons of CO2 equivalent) of 2008 in Italy to that in Kuwait?
Offer a terse response. 15.31. What is the ratio of the HFC emissions (in thousand metric tons of CO2 equivalent) of 1990 in Italy to that in Latvia?
Ensure brevity in your answer.  1.97e+04. What is the ratio of the HFC emissions (in thousand metric tons of CO2 equivalent) of 2000 in Italy to that in Latvia?
Keep it short and to the point. 37.37. What is the ratio of the HFC emissions (in thousand metric tons of CO2 equivalent) of 2005 in Italy to that in Latvia?
Provide a short and direct response. 10.4. What is the ratio of the HFC emissions (in thousand metric tons of CO2 equivalent) in 2008 in Italy to that in Latvia?
Your response must be concise. 9.67. What is the ratio of the HFC emissions (in thousand metric tons of CO2 equivalent) of 1990 in Japan to that in Korea (Democratic)?
Ensure brevity in your answer.  4.58e+04. What is the ratio of the HFC emissions (in thousand metric tons of CO2 equivalent) in 2000 in Japan to that in Korea (Democratic)?
Give a very brief answer. 19.4. What is the ratio of the HFC emissions (in thousand metric tons of CO2 equivalent) of 2005 in Japan to that in Korea (Democratic)?
Your answer should be very brief. 14.63. What is the ratio of the HFC emissions (in thousand metric tons of CO2 equivalent) in 2008 in Japan to that in Korea (Democratic)?
Ensure brevity in your answer.  14.31. What is the ratio of the HFC emissions (in thousand metric tons of CO2 equivalent) of 1990 in Japan to that in Korea (Republic)?
Keep it short and to the point. 4.81. What is the ratio of the HFC emissions (in thousand metric tons of CO2 equivalent) of 2000 in Japan to that in Korea (Republic)?
Make the answer very short. 4.08. What is the ratio of the HFC emissions (in thousand metric tons of CO2 equivalent) of 2005 in Japan to that in Korea (Republic)?
Keep it short and to the point. 8.26. What is the ratio of the HFC emissions (in thousand metric tons of CO2 equivalent) in 2008 in Japan to that in Korea (Republic)?
Offer a very short reply. 21.05. What is the ratio of the HFC emissions (in thousand metric tons of CO2 equivalent) of 1990 in Japan to that in Kuwait?
Give a very brief answer. 9.15e+04. What is the ratio of the HFC emissions (in thousand metric tons of CO2 equivalent) in 2000 in Japan to that in Kuwait?
Ensure brevity in your answer.  231.77. What is the ratio of the HFC emissions (in thousand metric tons of CO2 equivalent) in 2005 in Japan to that in Kuwait?
Keep it short and to the point. 75.55. What is the ratio of the HFC emissions (in thousand metric tons of CO2 equivalent) of 2008 in Japan to that in Kuwait?
Give a very brief answer. 67.87. What is the ratio of the HFC emissions (in thousand metric tons of CO2 equivalent) of 1990 in Japan to that in Latvia?
Your answer should be compact. 9.15e+04. What is the ratio of the HFC emissions (in thousand metric tons of CO2 equivalent) in 2000 in Japan to that in Latvia?
Your response must be concise. 179.68. What is the ratio of the HFC emissions (in thousand metric tons of CO2 equivalent) in 2005 in Japan to that in Latvia?
Your answer should be compact. 46.51. What is the ratio of the HFC emissions (in thousand metric tons of CO2 equivalent) in 2008 in Japan to that in Latvia?
Make the answer very short. 42.88. What is the ratio of the HFC emissions (in thousand metric tons of CO2 equivalent) in 1990 in Korea (Democratic) to that in Korea (Republic)?
Provide a short and direct response. 0. What is the ratio of the HFC emissions (in thousand metric tons of CO2 equivalent) of 2000 in Korea (Democratic) to that in Korea (Republic)?
Offer a very short reply. 0.21. What is the ratio of the HFC emissions (in thousand metric tons of CO2 equivalent) in 2005 in Korea (Democratic) to that in Korea (Republic)?
Your answer should be very brief. 0.56. What is the ratio of the HFC emissions (in thousand metric tons of CO2 equivalent) of 2008 in Korea (Democratic) to that in Korea (Republic)?
Offer a very short reply. 1.47. What is the ratio of the HFC emissions (in thousand metric tons of CO2 equivalent) of 2000 in Korea (Democratic) to that in Kuwait?
Your answer should be very brief. 11.95. What is the ratio of the HFC emissions (in thousand metric tons of CO2 equivalent) in 2005 in Korea (Democratic) to that in Kuwait?
Offer a very short reply. 5.17. What is the ratio of the HFC emissions (in thousand metric tons of CO2 equivalent) of 2008 in Korea (Democratic) to that in Kuwait?
Your answer should be compact. 4.74. What is the ratio of the HFC emissions (in thousand metric tons of CO2 equivalent) in 2000 in Korea (Democratic) to that in Latvia?
Provide a short and direct response. 9.26. What is the ratio of the HFC emissions (in thousand metric tons of CO2 equivalent) of 2005 in Korea (Democratic) to that in Latvia?
Offer a very short reply. 3.18. What is the ratio of the HFC emissions (in thousand metric tons of CO2 equivalent) of 2008 in Korea (Democratic) to that in Latvia?
Offer a very short reply. 3. What is the ratio of the HFC emissions (in thousand metric tons of CO2 equivalent) of 1990 in Korea (Republic) to that in Kuwait?
Keep it short and to the point. 1.90e+04. What is the ratio of the HFC emissions (in thousand metric tons of CO2 equivalent) in 2000 in Korea (Republic) to that in Kuwait?
Make the answer very short. 56.84. What is the ratio of the HFC emissions (in thousand metric tons of CO2 equivalent) of 2005 in Korea (Republic) to that in Kuwait?
Your response must be concise. 9.14. What is the ratio of the HFC emissions (in thousand metric tons of CO2 equivalent) in 2008 in Korea (Republic) to that in Kuwait?
Your answer should be very brief. 3.22. What is the ratio of the HFC emissions (in thousand metric tons of CO2 equivalent) in 1990 in Korea (Republic) to that in Latvia?
Offer a very short reply. 1.90e+04. What is the ratio of the HFC emissions (in thousand metric tons of CO2 equivalent) of 2000 in Korea (Republic) to that in Latvia?
Keep it short and to the point. 44.06. What is the ratio of the HFC emissions (in thousand metric tons of CO2 equivalent) of 2005 in Korea (Republic) to that in Latvia?
Make the answer very short. 5.63. What is the ratio of the HFC emissions (in thousand metric tons of CO2 equivalent) of 2008 in Korea (Republic) to that in Latvia?
Your response must be concise. 2.04. What is the ratio of the HFC emissions (in thousand metric tons of CO2 equivalent) in 1990 in Kuwait to that in Latvia?
Make the answer very short. 1. What is the ratio of the HFC emissions (in thousand metric tons of CO2 equivalent) in 2000 in Kuwait to that in Latvia?
Keep it short and to the point. 0.78. What is the ratio of the HFC emissions (in thousand metric tons of CO2 equivalent) of 2005 in Kuwait to that in Latvia?
Make the answer very short. 0.62. What is the ratio of the HFC emissions (in thousand metric tons of CO2 equivalent) of 2008 in Kuwait to that in Latvia?
Keep it short and to the point. 0.63. What is the difference between the highest and the second highest HFC emissions (in thousand metric tons of CO2 equivalent) in 1990?
Offer a terse response. 7182.1. What is the difference between the highest and the second highest HFC emissions (in thousand metric tons of CO2 equivalent) of 2000?
Provide a succinct answer. 2.58e+04. What is the difference between the highest and the second highest HFC emissions (in thousand metric tons of CO2 equivalent) in 2005?
Make the answer very short. 3.17e+04. What is the difference between the highest and the second highest HFC emissions (in thousand metric tons of CO2 equivalent) in 2008?
Provide a short and direct response. 4.09e+04. What is the difference between the highest and the lowest HFC emissions (in thousand metric tons of CO2 equivalent) in 1990?
Keep it short and to the point. 9154.2. What is the difference between the highest and the lowest HFC emissions (in thousand metric tons of CO2 equivalent) in 2000?
Ensure brevity in your answer.  3.40e+04. What is the difference between the highest and the lowest HFC emissions (in thousand metric tons of CO2 equivalent) of 2005?
Ensure brevity in your answer.  4.02e+04. What is the difference between the highest and the lowest HFC emissions (in thousand metric tons of CO2 equivalent) in 2008?
Keep it short and to the point. 5.21e+04. 